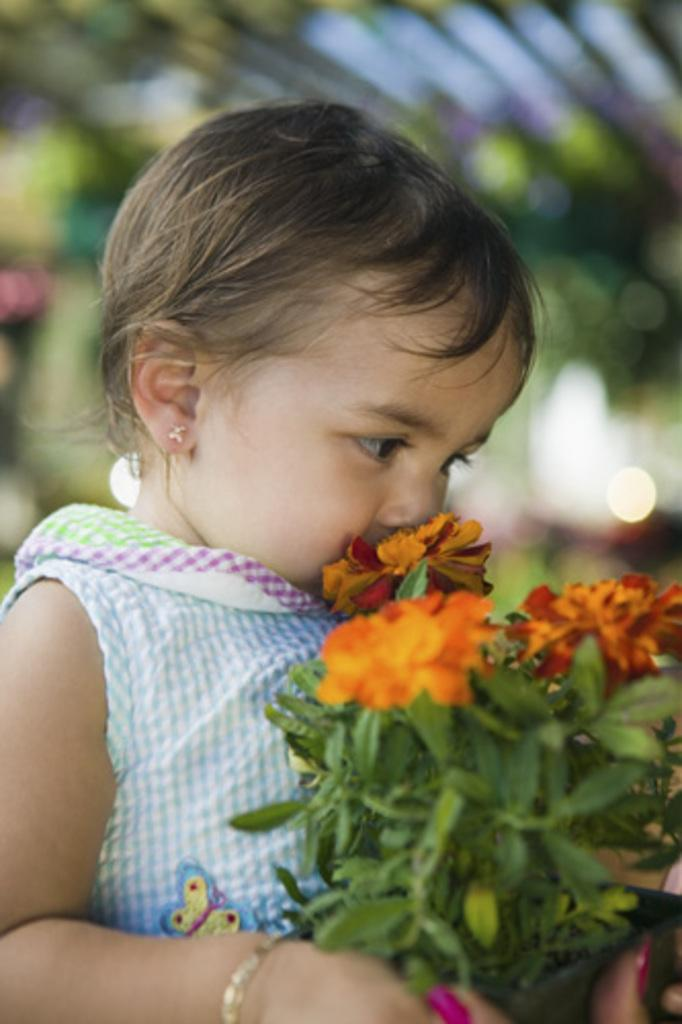Who is the main subject in the image? There is a girl in the image. What is the girl holding in her hands? The girl is holding a book in her hands. Can you describe the background of the image? The background of the image is blurred. What type of pin can be seen on the girl's shirt in the image? There is no pin visible on the girl's shirt in the image. What kind of music is playing in the background of the image? There is no music playing in the image, as it is a still photograph. 